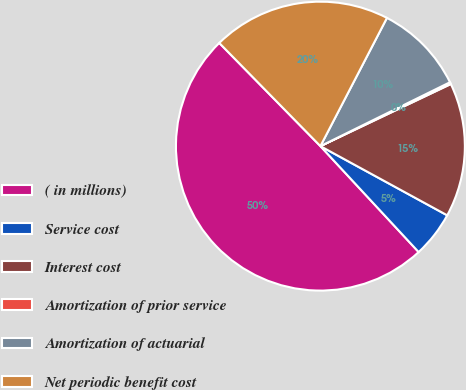<chart> <loc_0><loc_0><loc_500><loc_500><pie_chart><fcel>( in millions)<fcel>Service cost<fcel>Interest cost<fcel>Amortization of prior service<fcel>Amortization of actuarial<fcel>Net periodic benefit cost<nl><fcel>49.56%<fcel>5.15%<fcel>15.02%<fcel>0.22%<fcel>10.09%<fcel>19.96%<nl></chart> 